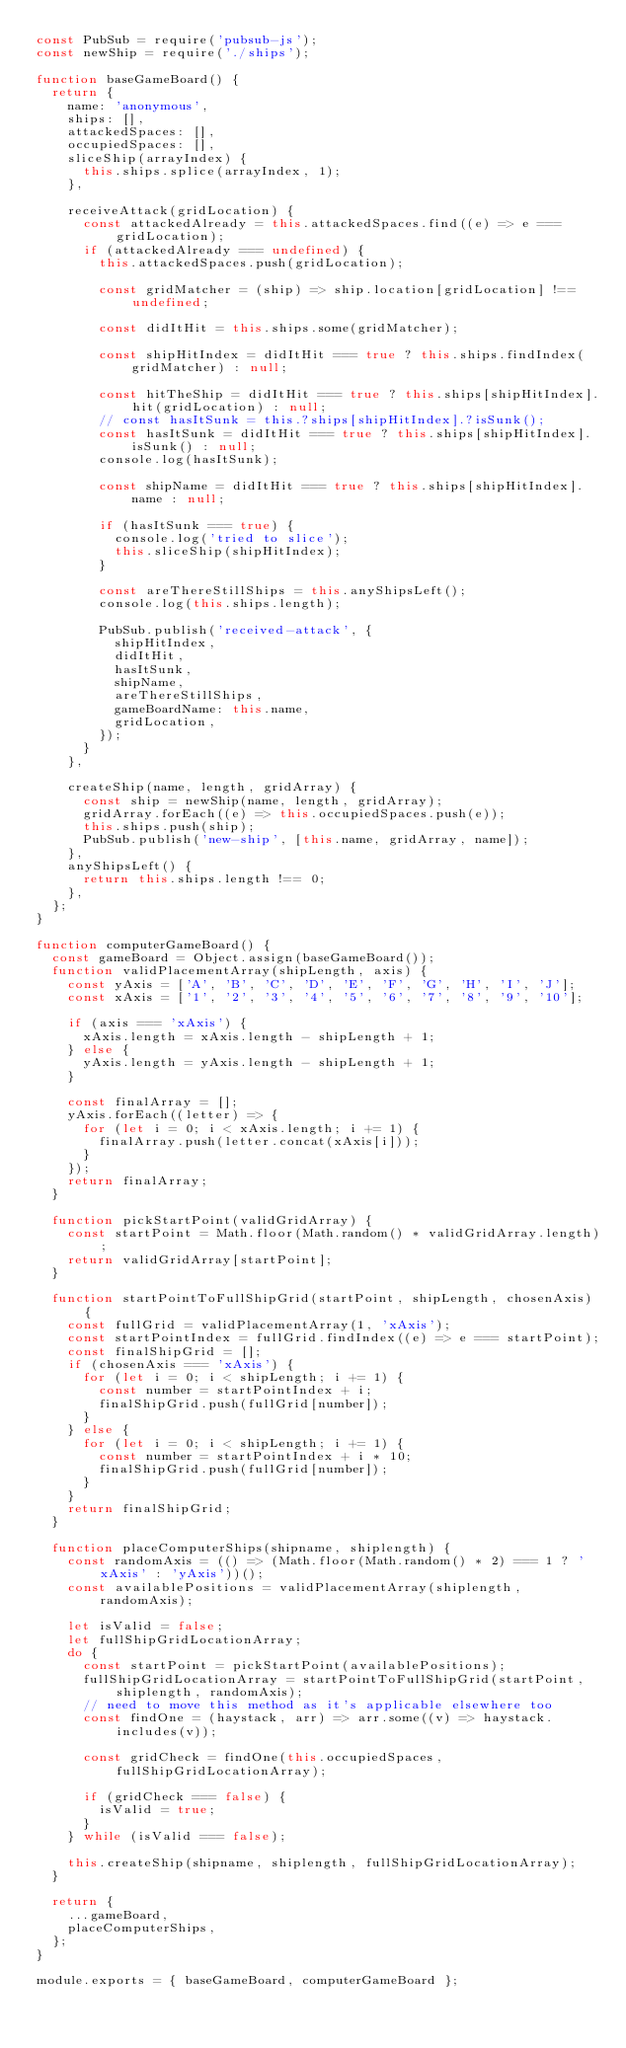Convert code to text. <code><loc_0><loc_0><loc_500><loc_500><_JavaScript_>const PubSub = require('pubsub-js');
const newShip = require('./ships');

function baseGameBoard() {
  return {
    name: 'anonymous',
    ships: [],
    attackedSpaces: [],
    occupiedSpaces: [],
    sliceShip(arrayIndex) {
      this.ships.splice(arrayIndex, 1);
    },

    receiveAttack(gridLocation) {
      const attackedAlready = this.attackedSpaces.find((e) => e === gridLocation);
      if (attackedAlready === undefined) {
        this.attackedSpaces.push(gridLocation);

        const gridMatcher = (ship) => ship.location[gridLocation] !== undefined;

        const didItHit = this.ships.some(gridMatcher);

        const shipHitIndex = didItHit === true ? this.ships.findIndex(gridMatcher) : null;

        const hitTheShip = didItHit === true ? this.ships[shipHitIndex].hit(gridLocation) : null;
        // const hasItSunk = this.?ships[shipHitIndex].?isSunk();
        const hasItSunk = didItHit === true ? this.ships[shipHitIndex].isSunk() : null;
        console.log(hasItSunk);

        const shipName = didItHit === true ? this.ships[shipHitIndex].name : null;

        if (hasItSunk === true) {
          console.log('tried to slice');
          this.sliceShip(shipHitIndex);
        }

        const areThereStillShips = this.anyShipsLeft();
        console.log(this.ships.length);

        PubSub.publish('received-attack', {
          shipHitIndex,
          didItHit,
          hasItSunk,
          shipName,
          areThereStillShips,
          gameBoardName: this.name,
          gridLocation,
        });
      }
    },

    createShip(name, length, gridArray) {
      const ship = newShip(name, length, gridArray);
      gridArray.forEach((e) => this.occupiedSpaces.push(e));
      this.ships.push(ship);
      PubSub.publish('new-ship', [this.name, gridArray, name]);
    },
    anyShipsLeft() {
      return this.ships.length !== 0;
    },
  };
}

function computerGameBoard() {
  const gameBoard = Object.assign(baseGameBoard());
  function validPlacementArray(shipLength, axis) {
    const yAxis = ['A', 'B', 'C', 'D', 'E', 'F', 'G', 'H', 'I', 'J'];
    const xAxis = ['1', '2', '3', '4', '5', '6', '7', '8', '9', '10'];

    if (axis === 'xAxis') {
      xAxis.length = xAxis.length - shipLength + 1;
    } else {
      yAxis.length = yAxis.length - shipLength + 1;
    }

    const finalArray = [];
    yAxis.forEach((letter) => {
      for (let i = 0; i < xAxis.length; i += 1) {
        finalArray.push(letter.concat(xAxis[i]));
      }
    });
    return finalArray;
  }

  function pickStartPoint(validGridArray) {
    const startPoint = Math.floor(Math.random() * validGridArray.length);
    return validGridArray[startPoint];
  }

  function startPointToFullShipGrid(startPoint, shipLength, chosenAxis) {
    const fullGrid = validPlacementArray(1, 'xAxis');
    const startPointIndex = fullGrid.findIndex((e) => e === startPoint);
    const finalShipGrid = [];
    if (chosenAxis === 'xAxis') {
      for (let i = 0; i < shipLength; i += 1) {
        const number = startPointIndex + i;
        finalShipGrid.push(fullGrid[number]);
      }
    } else {
      for (let i = 0; i < shipLength; i += 1) {
        const number = startPointIndex + i * 10;
        finalShipGrid.push(fullGrid[number]);
      }
    }
    return finalShipGrid;
  }

  function placeComputerShips(shipname, shiplength) {
    const randomAxis = (() => (Math.floor(Math.random() * 2) === 1 ? 'xAxis' : 'yAxis'))();
    const availablePositions = validPlacementArray(shiplength, randomAxis);

    let isValid = false;
    let fullShipGridLocationArray;
    do {
      const startPoint = pickStartPoint(availablePositions);
      fullShipGridLocationArray = startPointToFullShipGrid(startPoint, shiplength, randomAxis);
      // need to move this method as it's applicable elsewhere too
      const findOne = (haystack, arr) => arr.some((v) => haystack.includes(v));

      const gridCheck = findOne(this.occupiedSpaces, fullShipGridLocationArray);

      if (gridCheck === false) {
        isValid = true;
      }
    } while (isValid === false);

    this.createShip(shipname, shiplength, fullShipGridLocationArray);
  }

  return {
    ...gameBoard,
    placeComputerShips,
  };
}

module.exports = { baseGameBoard, computerGameBoard };
</code> 